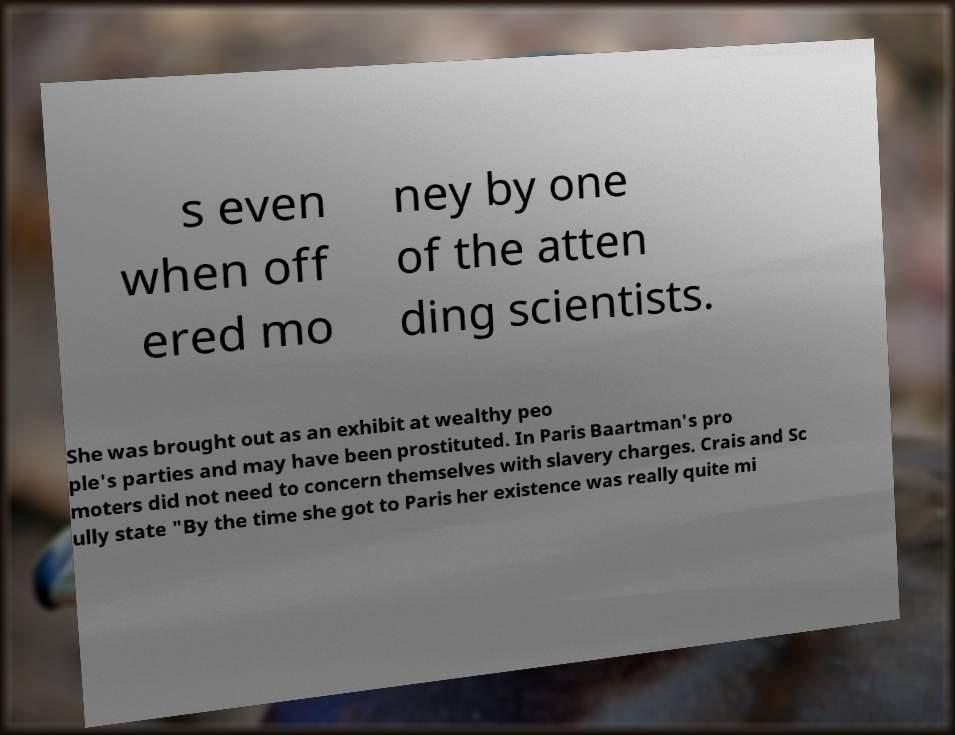Can you accurately transcribe the text from the provided image for me? s even when off ered mo ney by one of the atten ding scientists. She was brought out as an exhibit at wealthy peo ple's parties and may have been prostituted. In Paris Baartman's pro moters did not need to concern themselves with slavery charges. Crais and Sc ully state "By the time she got to Paris her existence was really quite mi 